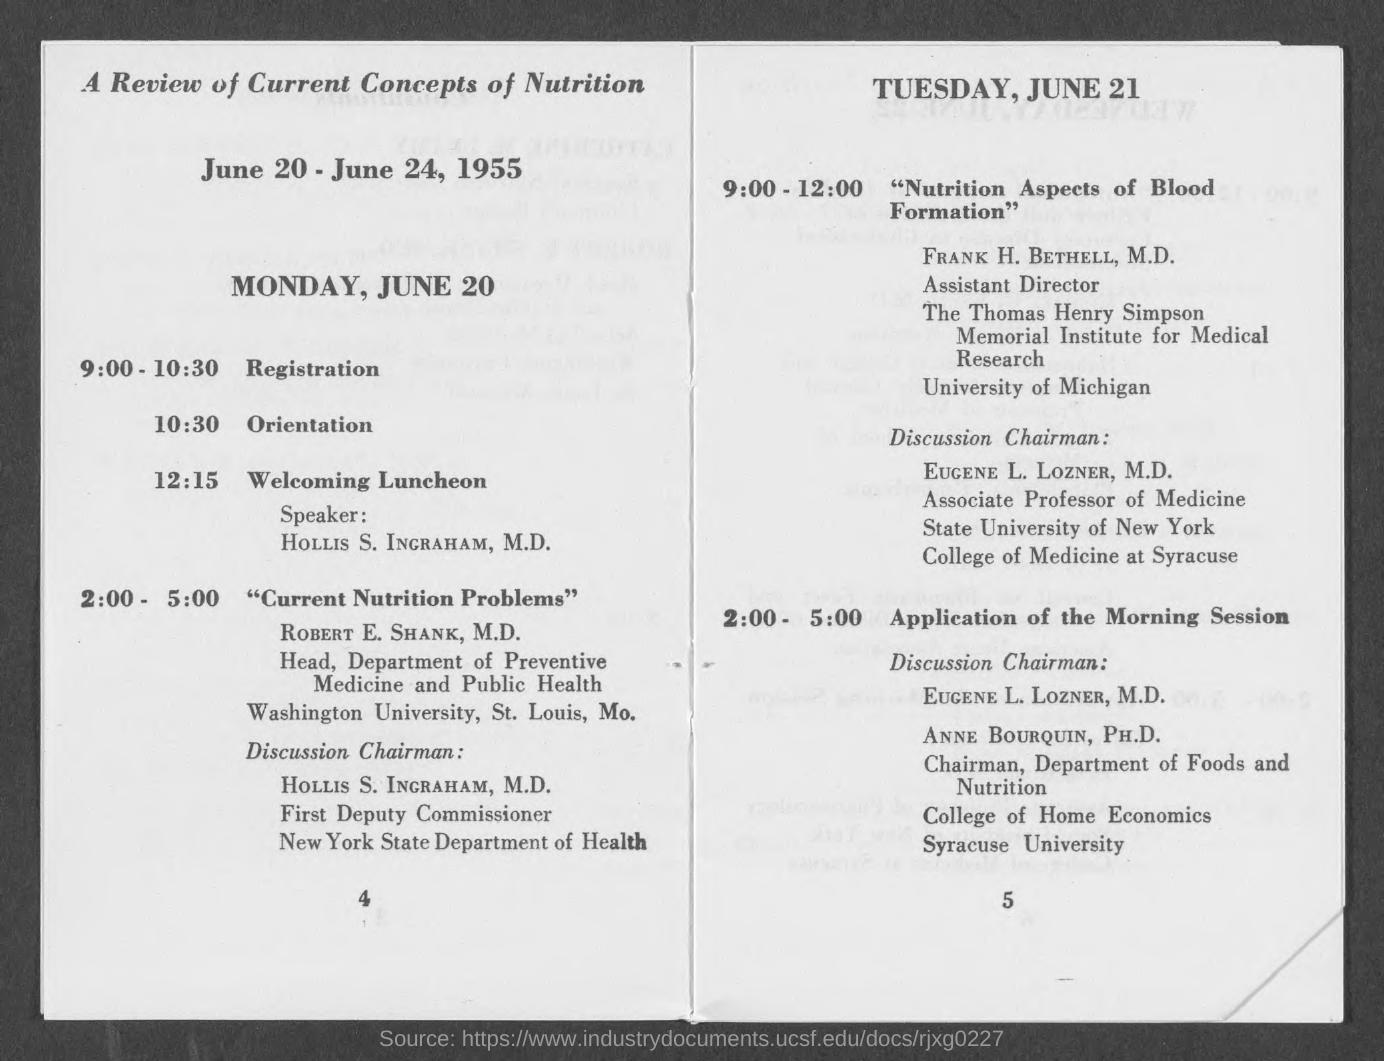What time is the registration for the sessions done?
Provide a short and direct response. 9:00 - 10:30. What time is the orientation for the sessions held on Monday, June 20?
Offer a terse response. 10:30. What is the designation of ROBERT E. SHANK, M.D.?
Offer a terse response. Head, Department of Preventive Medicine and Public Health. Who is the discussion chairman for the session on "Nutrition Aspects of Blood Formation"?
Make the answer very short. EUGENE L. LOZNER, M.D. What topic is discussed on Monday, June 20 at 2:00 - 5:00?
Offer a terse response. "Current Nutrition Problems". 